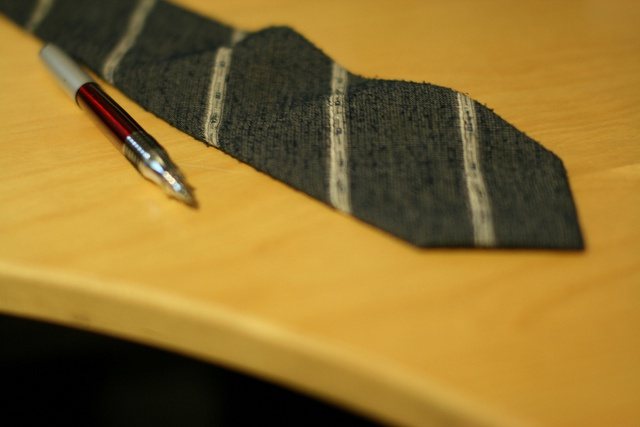Describe the objects in this image and their specific colors. I can see a tie in black, darkgreen, and tan tones in this image. 